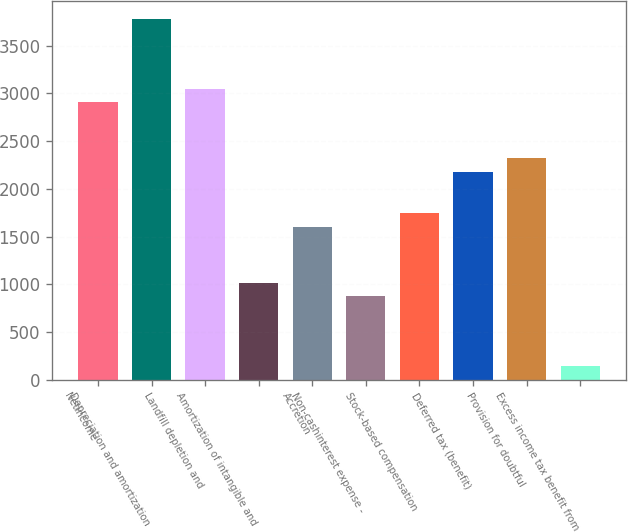<chart> <loc_0><loc_0><loc_500><loc_500><bar_chart><fcel>Netincome<fcel>Depreciation and amortization<fcel>Landfill depletion and<fcel>Amortization of intangible and<fcel>Accretion<fcel>Non-cashinterest expense -<fcel>Stock-based compensation<fcel>Deferred tax (benefit)<fcel>Provision for doubtful<fcel>Excess income tax benefit from<nl><fcel>2905.4<fcel>3776.6<fcel>3050.6<fcel>1017.8<fcel>1598.6<fcel>872.6<fcel>1743.8<fcel>2179.4<fcel>2324.6<fcel>146.6<nl></chart> 